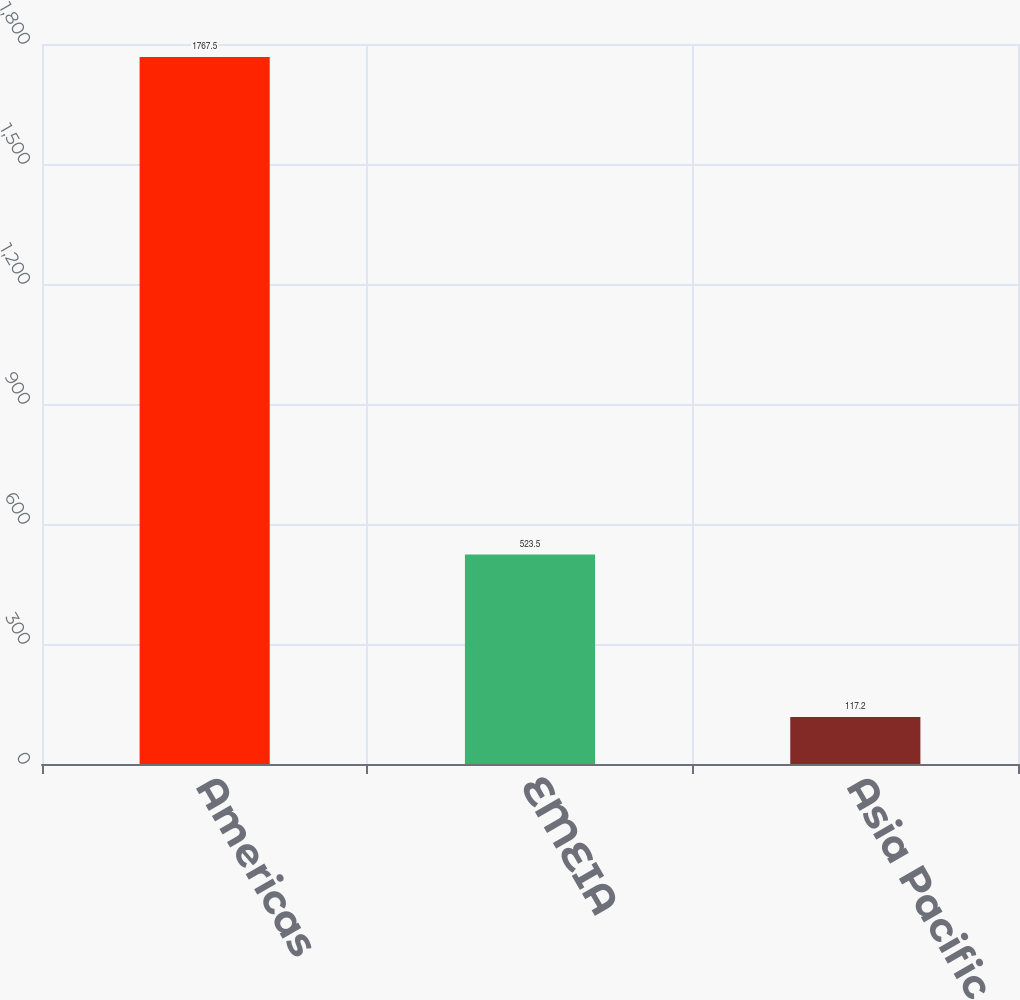<chart> <loc_0><loc_0><loc_500><loc_500><bar_chart><fcel>Americas<fcel>EMEIA<fcel>Asia Pacific<nl><fcel>1767.5<fcel>523.5<fcel>117.2<nl></chart> 